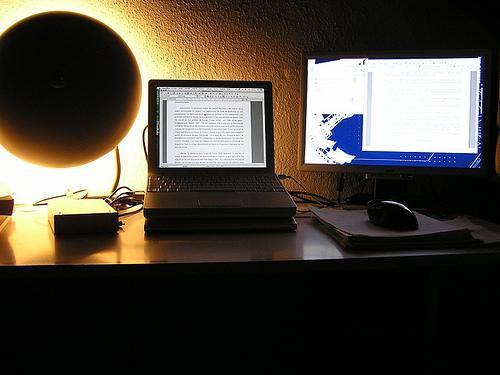How many laptops are there?
Give a very brief answer. 1. How many giraffes in the scene?
Give a very brief answer. 0. 